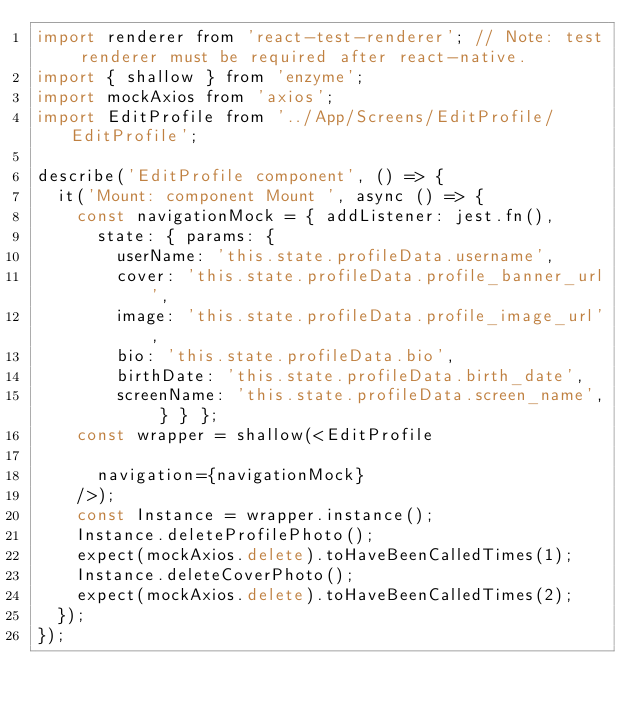Convert code to text. <code><loc_0><loc_0><loc_500><loc_500><_JavaScript_>import renderer from 'react-test-renderer'; // Note: test renderer must be required after react-native.
import { shallow } from 'enzyme';
import mockAxios from 'axios';
import EditProfile from '../App/Screens/EditProfile/EditProfile';

describe('EditProfile component', () => {
  it('Mount: component Mount ', async () => {
    const navigationMock = { addListener: jest.fn(),
      state: { params: {
        userName: 'this.state.profileData.username',
        cover: 'this.state.profileData.profile_banner_url',
        image: 'this.state.profileData.profile_image_url',
        bio: 'this.state.profileData.bio',
        birthDate: 'this.state.profileData.birth_date',
        screenName: 'this.state.profileData.screen_name', } } };
    const wrapper = shallow(<EditProfile

      navigation={navigationMock}
    />);
    const Instance = wrapper.instance();
    Instance.deleteProfilePhoto();
    expect(mockAxios.delete).toHaveBeenCalledTimes(1);
    Instance.deleteCoverPhoto();
    expect(mockAxios.delete).toHaveBeenCalledTimes(2);
  });
});</code> 